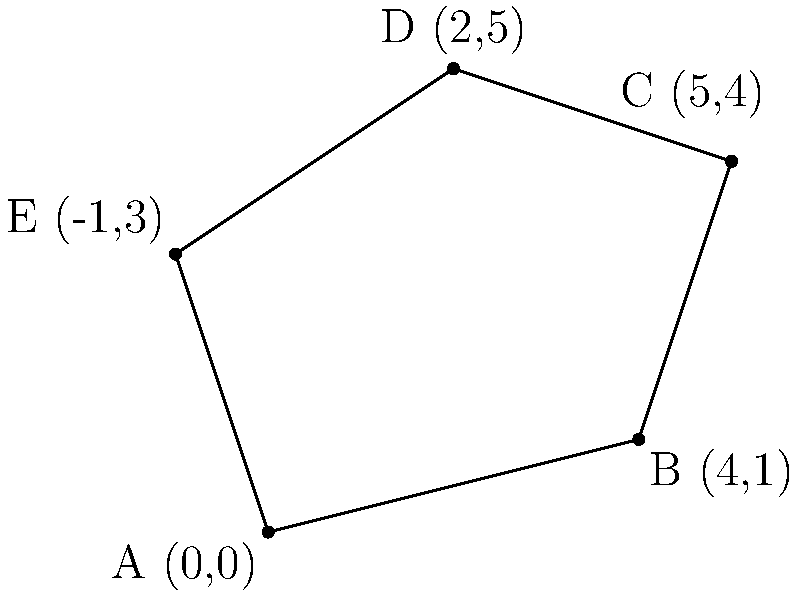Given the GPS coordinates of an irregular polygon ABCDE: A(0,0), B(4,1), C(5,4), D(2,5), and E(-1,3), calculate its area using the Shoelace formula. Round your answer to two decimal places. To calculate the area of an irregular polygon using the Shoelace formula, we follow these steps:

1) The Shoelace formula for a polygon with vertices $(x_1, y_1), (x_2, y_2), ..., (x_n, y_n)$ is:

   Area = $\frac{1}{2}|[(x_1y_2 + x_2y_3 + ... + x_ny_1) - (y_1x_2 + y_2x_3 + ... + y_nx_1)]|$

2) For our polygon ABCDE, we have:
   A(0,0), B(4,1), C(5,4), D(2,5), E(-1,3)

3) Let's calculate the first part $(x_1y_2 + x_2y_3 + ... + x_ny_1)$:
   $(0 \cdot 1) + (4 \cdot 4) + (5 \cdot 5) + (2 \cdot 3) + (-1 \cdot 0) = 0 + 16 + 25 + 6 + 0 = 47$

4) Now, let's calculate the second part $(y_1x_2 + y_2x_3 + ... + y_nx_1)$:
   $(0 \cdot 4) + (1 \cdot 5) + (4 \cdot 2) + (5 \cdot -1) + (3 \cdot 0) = 0 + 5 + 8 - 5 + 0 = 8$

5) Subtracting the second part from the first:
   $47 - 8 = 39$

6) Taking the absolute value and dividing by 2:
   Area = $\frac{1}{2}|39| = \frac{39}{2} = 19.5$

Therefore, the area of the polygon is 19.5 square units.
Answer: 19.50 square units 